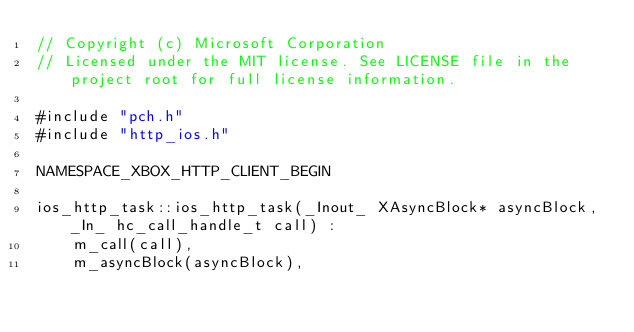<code> <loc_0><loc_0><loc_500><loc_500><_ObjectiveC_>// Copyright (c) Microsoft Corporation
// Licensed under the MIT license. See LICENSE file in the project root for full license information.

#include "pch.h"
#include "http_ios.h"

NAMESPACE_XBOX_HTTP_CLIENT_BEGIN

ios_http_task::ios_http_task(_Inout_ XAsyncBlock* asyncBlock, _In_ hc_call_handle_t call) :
    m_call(call),
    m_asyncBlock(asyncBlock),</code> 